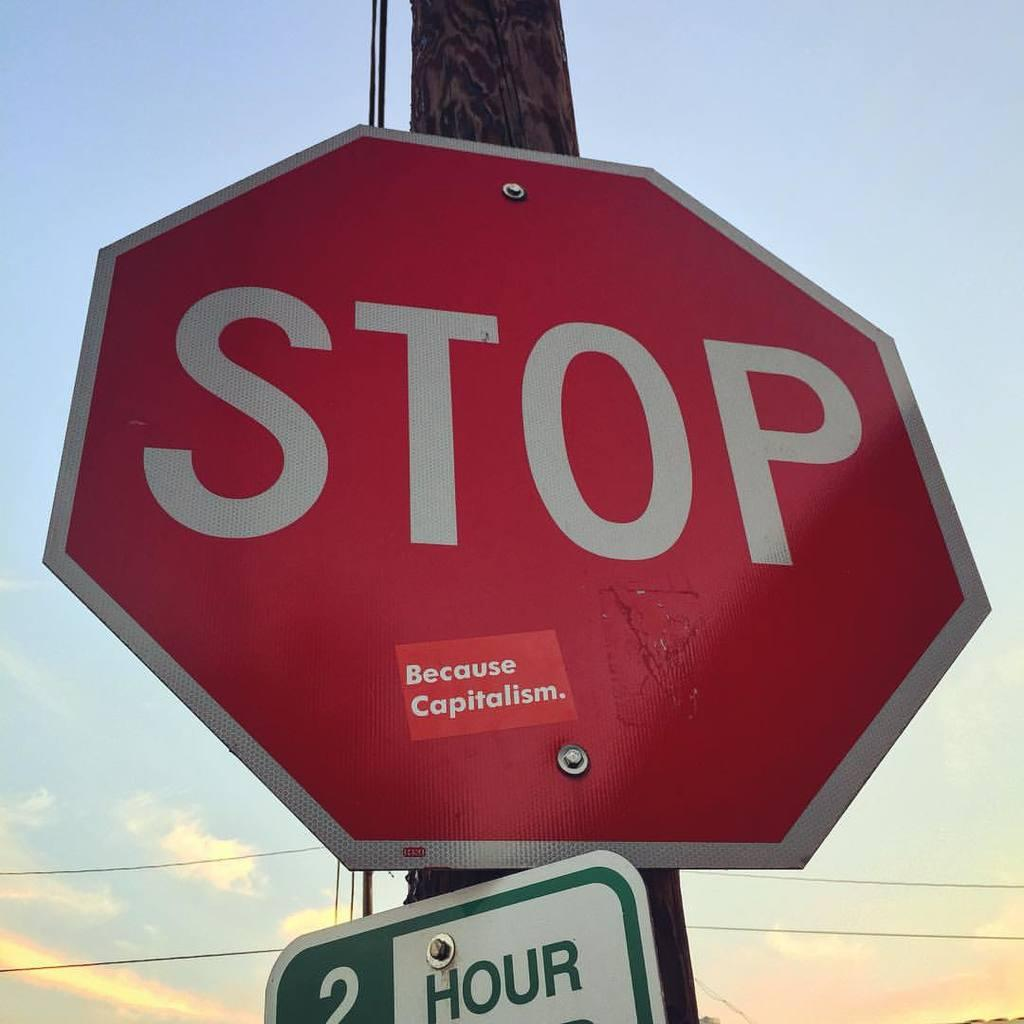Provide a one-sentence caption for the provided image. a stop sign that is located above a 2 hour sign. 